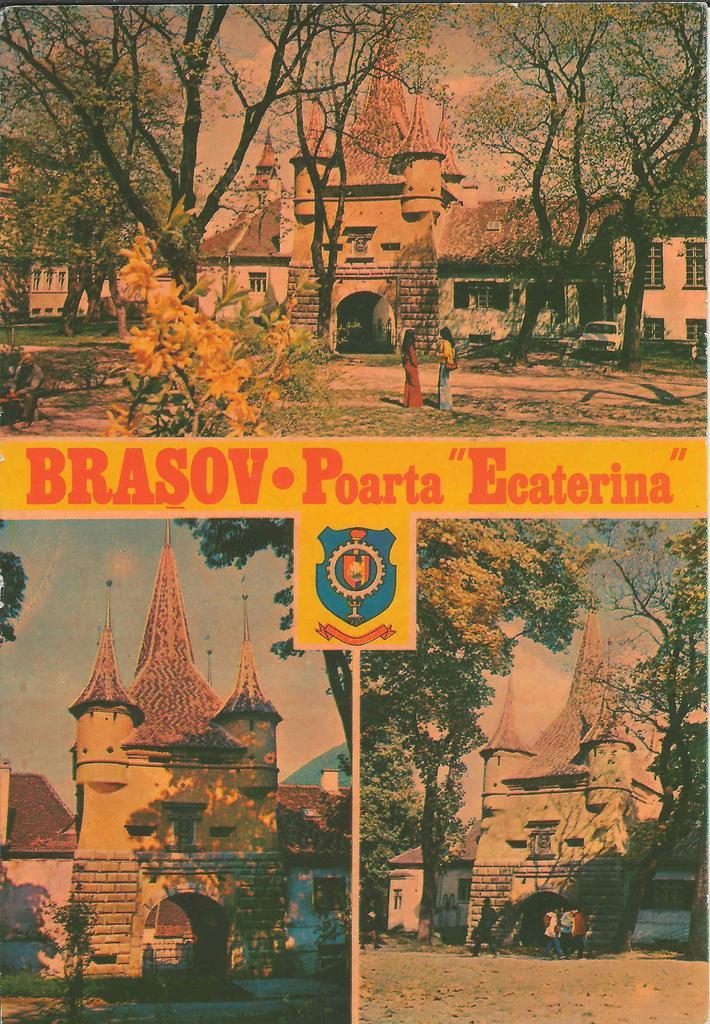How would you summarize this image in a sentence or two? This image looks like an edited photo in which I can see buildings, trees, crowd on the road, plants, flag, vehicles and the sky. 